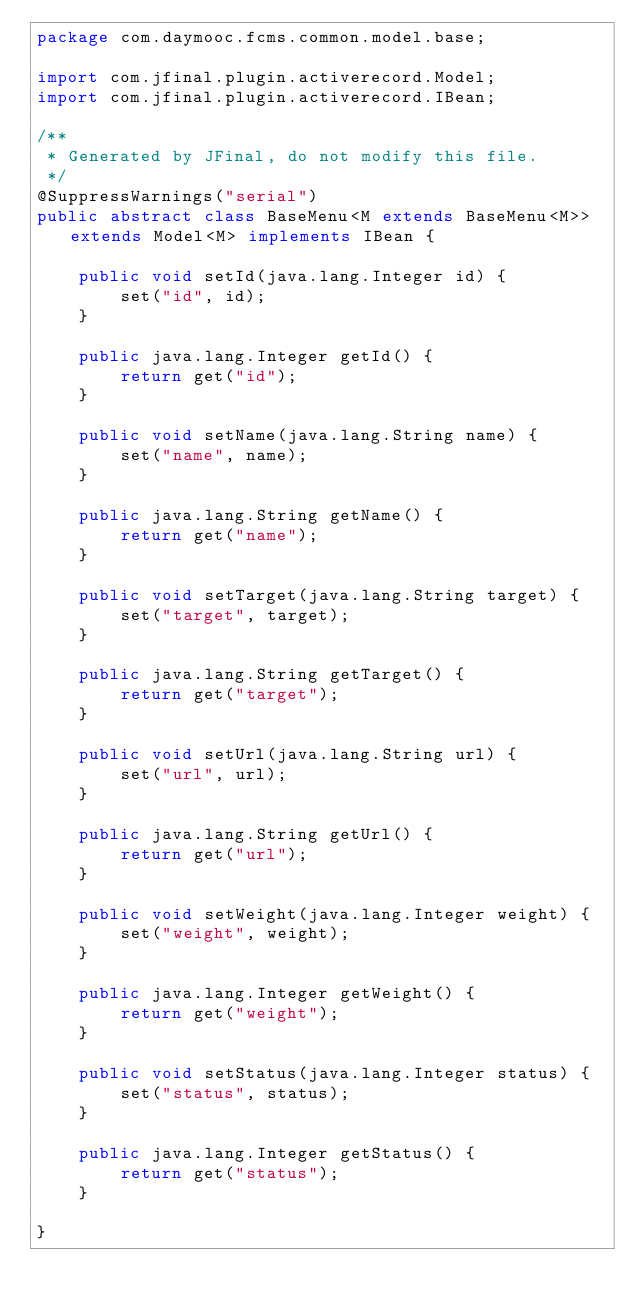<code> <loc_0><loc_0><loc_500><loc_500><_Java_>package com.daymooc.fcms.common.model.base;

import com.jfinal.plugin.activerecord.Model;
import com.jfinal.plugin.activerecord.IBean;

/**
 * Generated by JFinal, do not modify this file.
 */
@SuppressWarnings("serial")
public abstract class BaseMenu<M extends BaseMenu<M>> extends Model<M> implements IBean {

	public void setId(java.lang.Integer id) {
		set("id", id);
	}

	public java.lang.Integer getId() {
		return get("id");
	}

	public void setName(java.lang.String name) {
		set("name", name);
	}

	public java.lang.String getName() {
		return get("name");
	}

	public void setTarget(java.lang.String target) {
		set("target", target);
	}

	public java.lang.String getTarget() {
		return get("target");
	}

	public void setUrl(java.lang.String url) {
		set("url", url);
	}

	public java.lang.String getUrl() {
		return get("url");
	}

	public void setWeight(java.lang.Integer weight) {
		set("weight", weight);
	}

	public java.lang.Integer getWeight() {
		return get("weight");
	}

	public void setStatus(java.lang.Integer status) {
		set("status", status);
	}

	public java.lang.Integer getStatus() {
		return get("status");
	}

}
</code> 